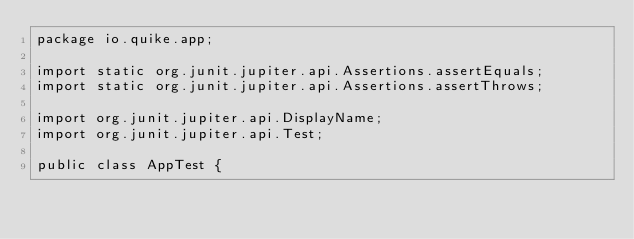Convert code to text. <code><loc_0><loc_0><loc_500><loc_500><_Java_>package io.quike.app;

import static org.junit.jupiter.api.Assertions.assertEquals;
import static org.junit.jupiter.api.Assertions.assertThrows;

import org.junit.jupiter.api.DisplayName;
import org.junit.jupiter.api.Test;

public class AppTest {
</code> 